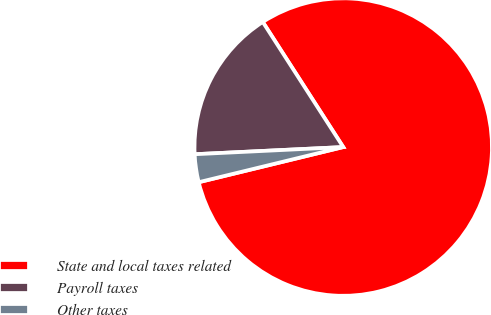Convert chart. <chart><loc_0><loc_0><loc_500><loc_500><pie_chart><fcel>State and local taxes related<fcel>Payroll taxes<fcel>Other taxes<nl><fcel>80.3%<fcel>16.67%<fcel>3.03%<nl></chart> 